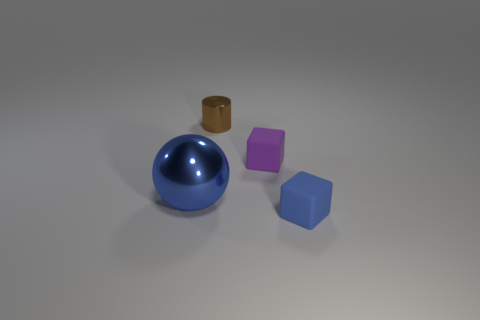What objects can you identify in this image, and what are their colors? In the image, there is a shiny blue sphere, a small brown cylinder, a violet cube, and a blue cube, all arranged on a light gray surface. 